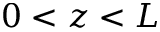<formula> <loc_0><loc_0><loc_500><loc_500>0 < z < L</formula> 